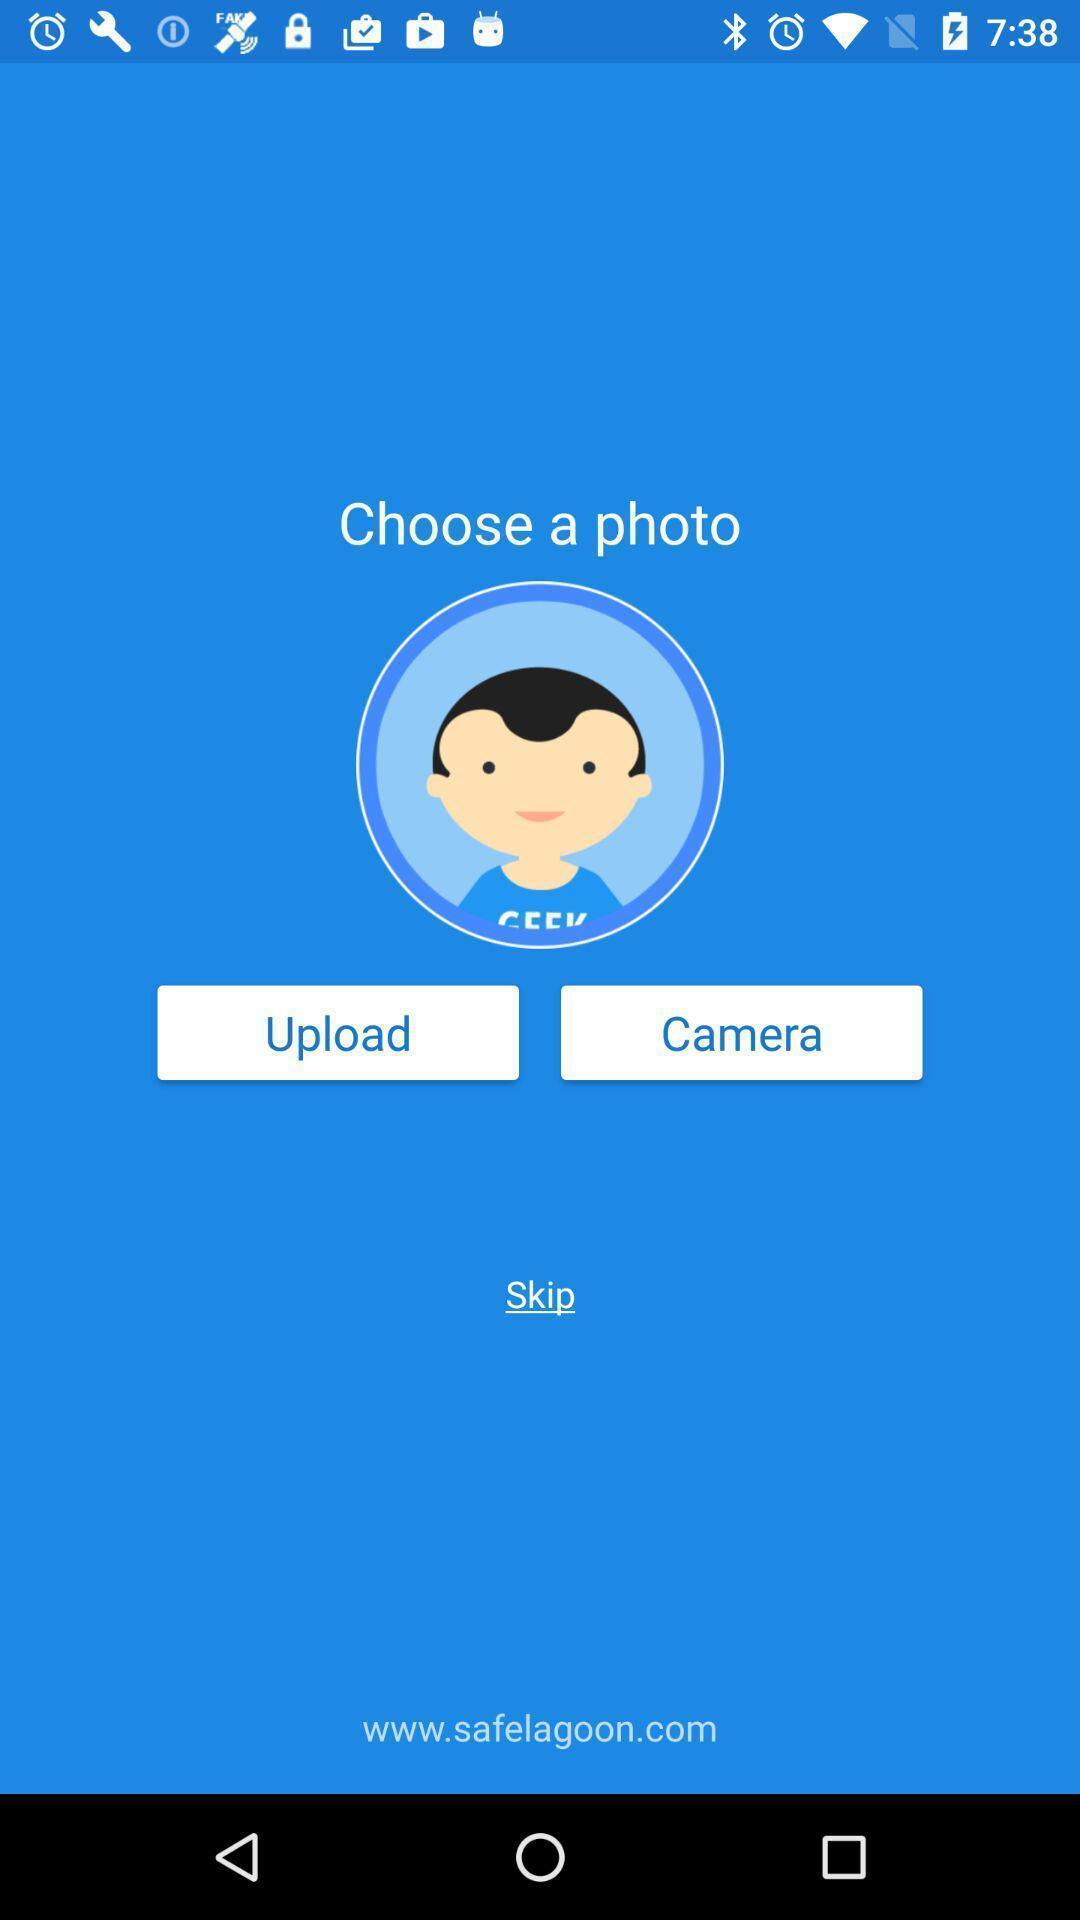Describe this image in words. Screen showing choose a photo option. 